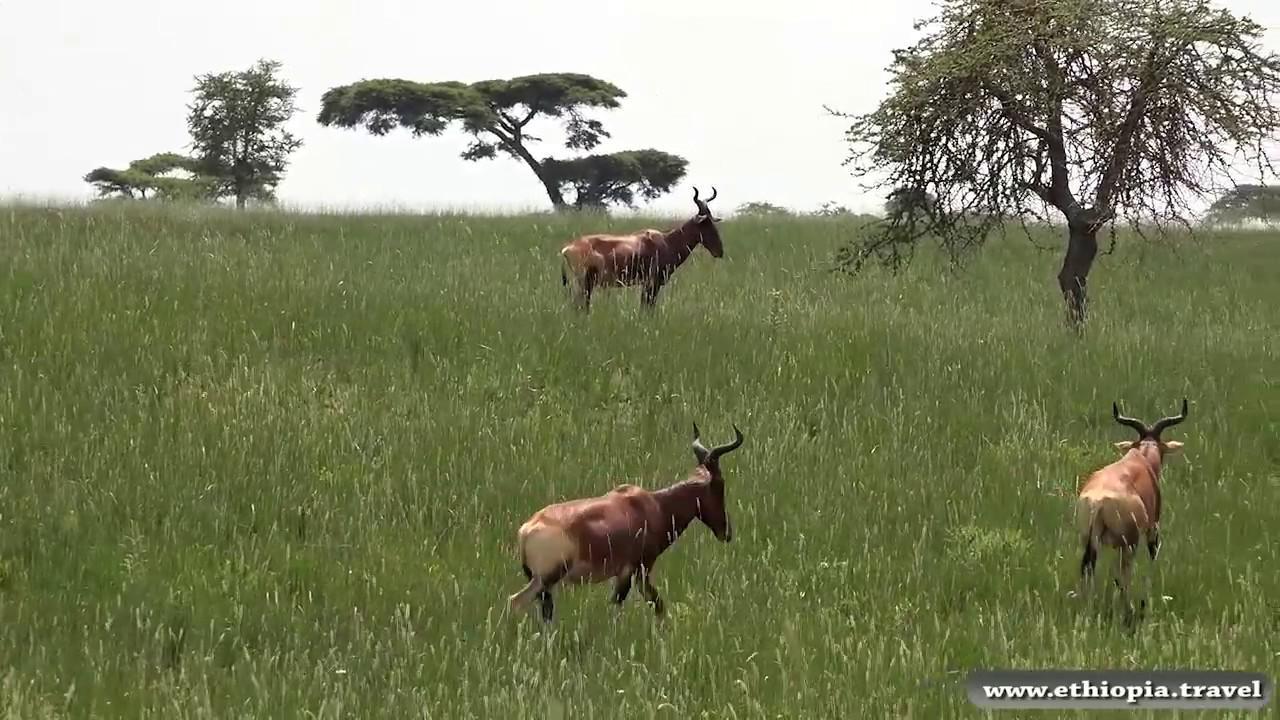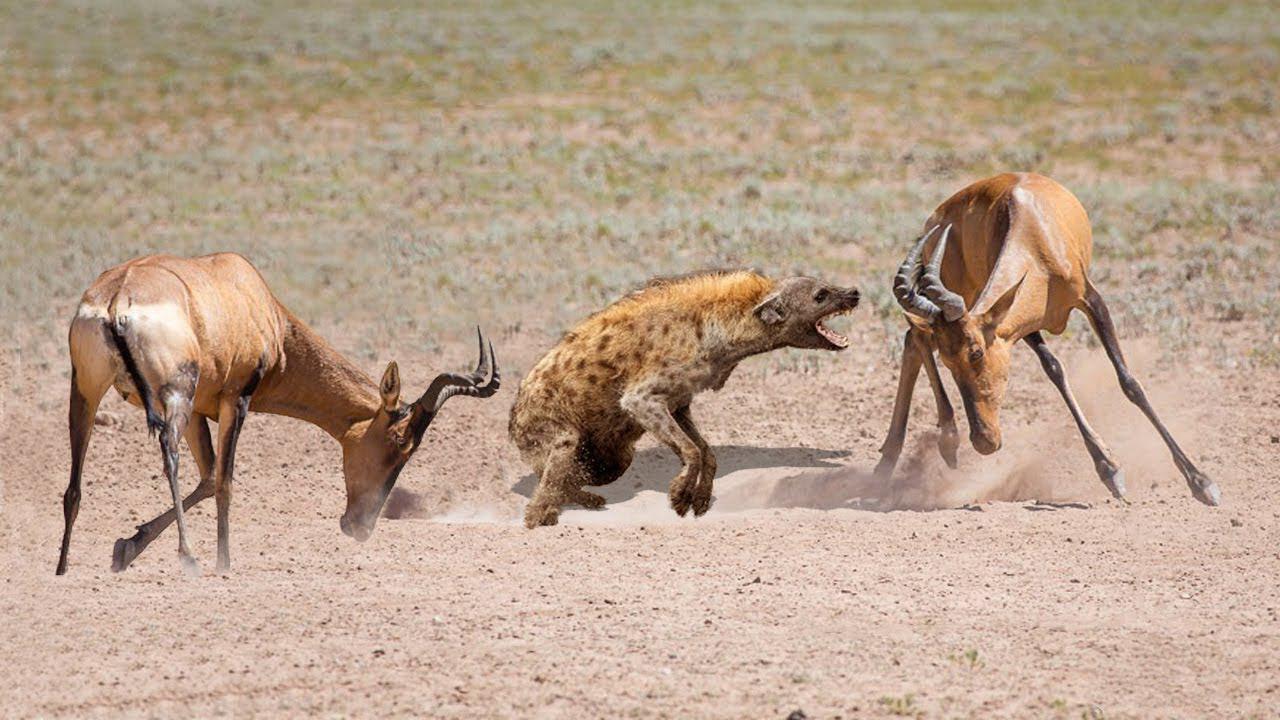The first image is the image on the left, the second image is the image on the right. Analyze the images presented: Is the assertion "There are exactly two animals standing." valid? Answer yes or no. No. 